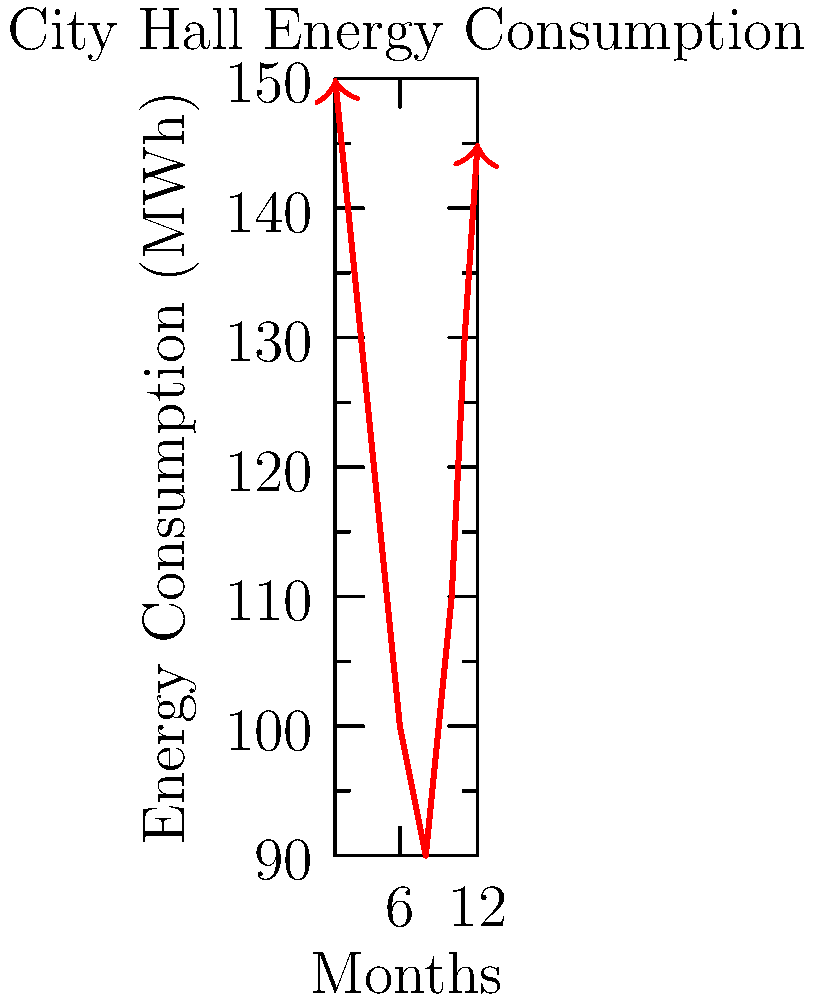As a mayoral candidate proposing energy efficiency measures, analyze the given graph of monthly energy consumption for the City Hall. If you implement measures to reduce energy usage by 15% during the highest consumption months (December to February) and 10% during the rest of the year, what would be the total annual energy savings in MWh? To solve this problem, we'll follow these steps:

1. Identify the highest consumption months (December to February):
   December: 145 MWh
   January: 150 MWh
   February: 140 MWh

2. Calculate 15% reduction for these months:
   December: $145 \times 0.15 = 21.75$ MWh
   January: $150 \times 0.15 = 22.5$ MWh
   February: $140 \times 0.15 = 21$ MWh
   Total high-consumption months savings: $21.75 + 22.5 + 21 = 65.25$ MWh

3. Calculate 10% reduction for the remaining months:
   March: $130 \times 0.10 = 13$ MWh
   April: $120 \times 0.10 = 12$ MWh
   May: $110 \times 0.10 = 11$ MWh
   June: $100 \times 0.10 = 10$ MWh
   July: $95 \times 0.10 = 9.5$ MWh
   August: $90 \times 0.10 = 9$ MWh
   September: $100 \times 0.10 = 10$ MWh
   October: $110 \times 0.10 = 11$ MWh
   November: $130 \times 0.10 = 13$ MWh
   Total other months savings: $13 + 12 + 11 + 10 + 9.5 + 9 + 10 + 11 + 13 = 98.5$ MWh

4. Sum up the total savings:
   Total annual savings = High-consumption months savings + Other months savings
   $= 65.25 + 98.5 = 163.75$ MWh
Answer: 163.75 MWh 